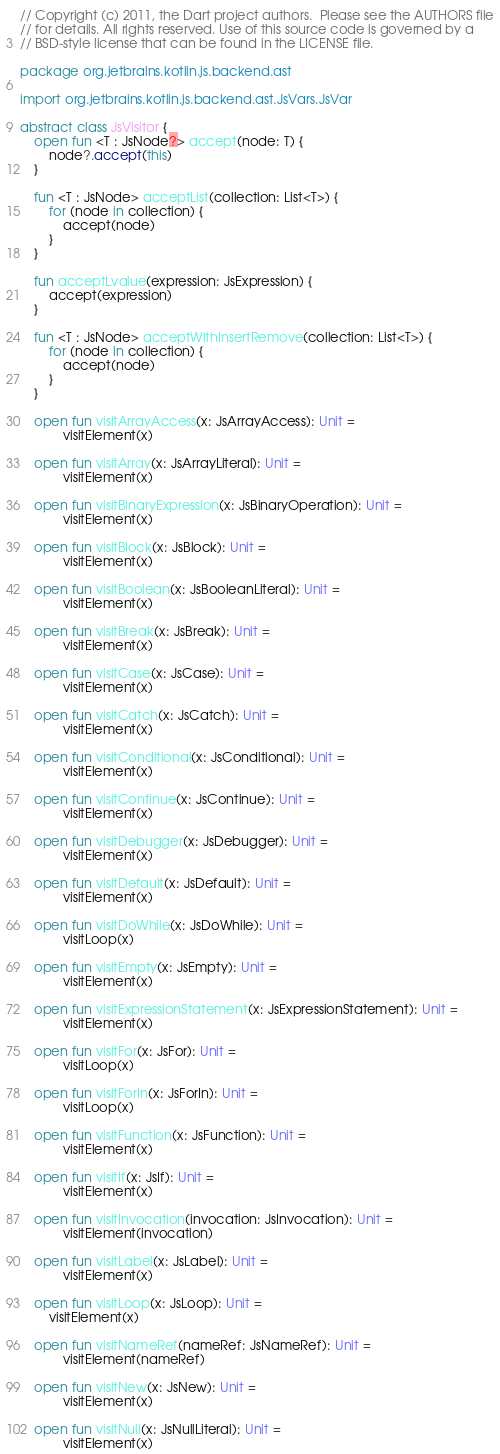Convert code to text. <code><loc_0><loc_0><loc_500><loc_500><_Kotlin_>// Copyright (c) 2011, the Dart project authors.  Please see the AUTHORS file
// for details. All rights reserved. Use of this source code is governed by a
// BSD-style license that can be found in the LICENSE file.

package org.jetbrains.kotlin.js.backend.ast

import org.jetbrains.kotlin.js.backend.ast.JsVars.JsVar

abstract class JsVisitor {
    open fun <T : JsNode?> accept(node: T) {
        node?.accept(this)
    }

    fun <T : JsNode> acceptList(collection: List<T>) {
        for (node in collection) {
            accept(node)
        }
    }

    fun acceptLvalue(expression: JsExpression) {
        accept(expression)
    }

    fun <T : JsNode> acceptWithInsertRemove(collection: List<T>) {
        for (node in collection) {
            accept(node)
        }
    }

    open fun visitArrayAccess(x: JsArrayAccess): Unit =
            visitElement(x)

    open fun visitArray(x: JsArrayLiteral): Unit =
            visitElement(x)

    open fun visitBinaryExpression(x: JsBinaryOperation): Unit =
            visitElement(x)

    open fun visitBlock(x: JsBlock): Unit =
            visitElement(x)

    open fun visitBoolean(x: JsBooleanLiteral): Unit =
            visitElement(x)

    open fun visitBreak(x: JsBreak): Unit =
            visitElement(x)

    open fun visitCase(x: JsCase): Unit =
            visitElement(x)

    open fun visitCatch(x: JsCatch): Unit =
            visitElement(x)

    open fun visitConditional(x: JsConditional): Unit =
            visitElement(x)

    open fun visitContinue(x: JsContinue): Unit =
            visitElement(x)

    open fun visitDebugger(x: JsDebugger): Unit =
            visitElement(x)

    open fun visitDefault(x: JsDefault): Unit =
            visitElement(x)

    open fun visitDoWhile(x: JsDoWhile): Unit =
            visitLoop(x)

    open fun visitEmpty(x: JsEmpty): Unit =
            visitElement(x)

    open fun visitExpressionStatement(x: JsExpressionStatement): Unit =
            visitElement(x)

    open fun visitFor(x: JsFor): Unit =
            visitLoop(x)

    open fun visitForIn(x: JsForIn): Unit =
            visitLoop(x)

    open fun visitFunction(x: JsFunction): Unit =
            visitElement(x)

    open fun visitIf(x: JsIf): Unit =
            visitElement(x)

    open fun visitInvocation(invocation: JsInvocation): Unit =
            visitElement(invocation)

    open fun visitLabel(x: JsLabel): Unit =
            visitElement(x)

    open fun visitLoop(x: JsLoop): Unit =
        visitElement(x)

    open fun visitNameRef(nameRef: JsNameRef): Unit =
            visitElement(nameRef)

    open fun visitNew(x: JsNew): Unit =
            visitElement(x)

    open fun visitNull(x: JsNullLiteral): Unit =
            visitElement(x)
</code> 